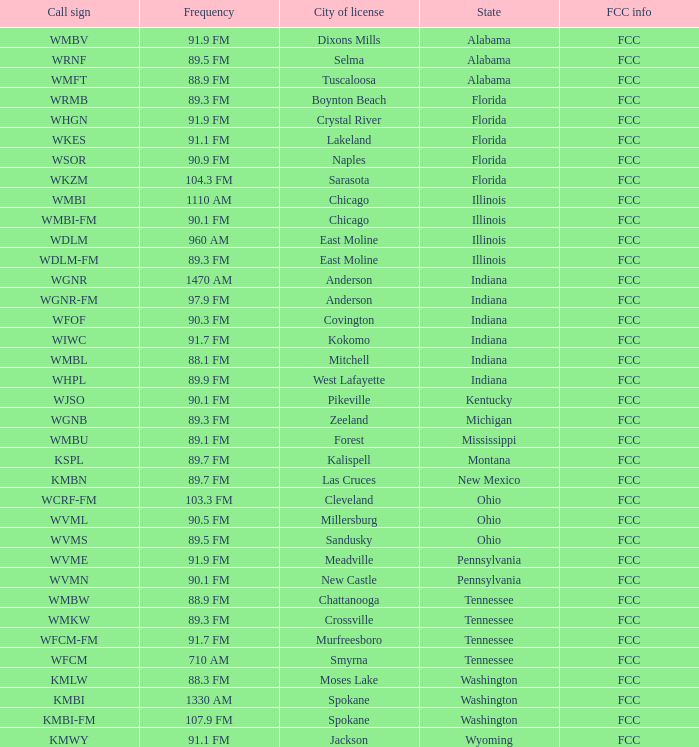What is the rate of recurrence for the radio station in indiana with a call sign wgnr? 1470 AM. 